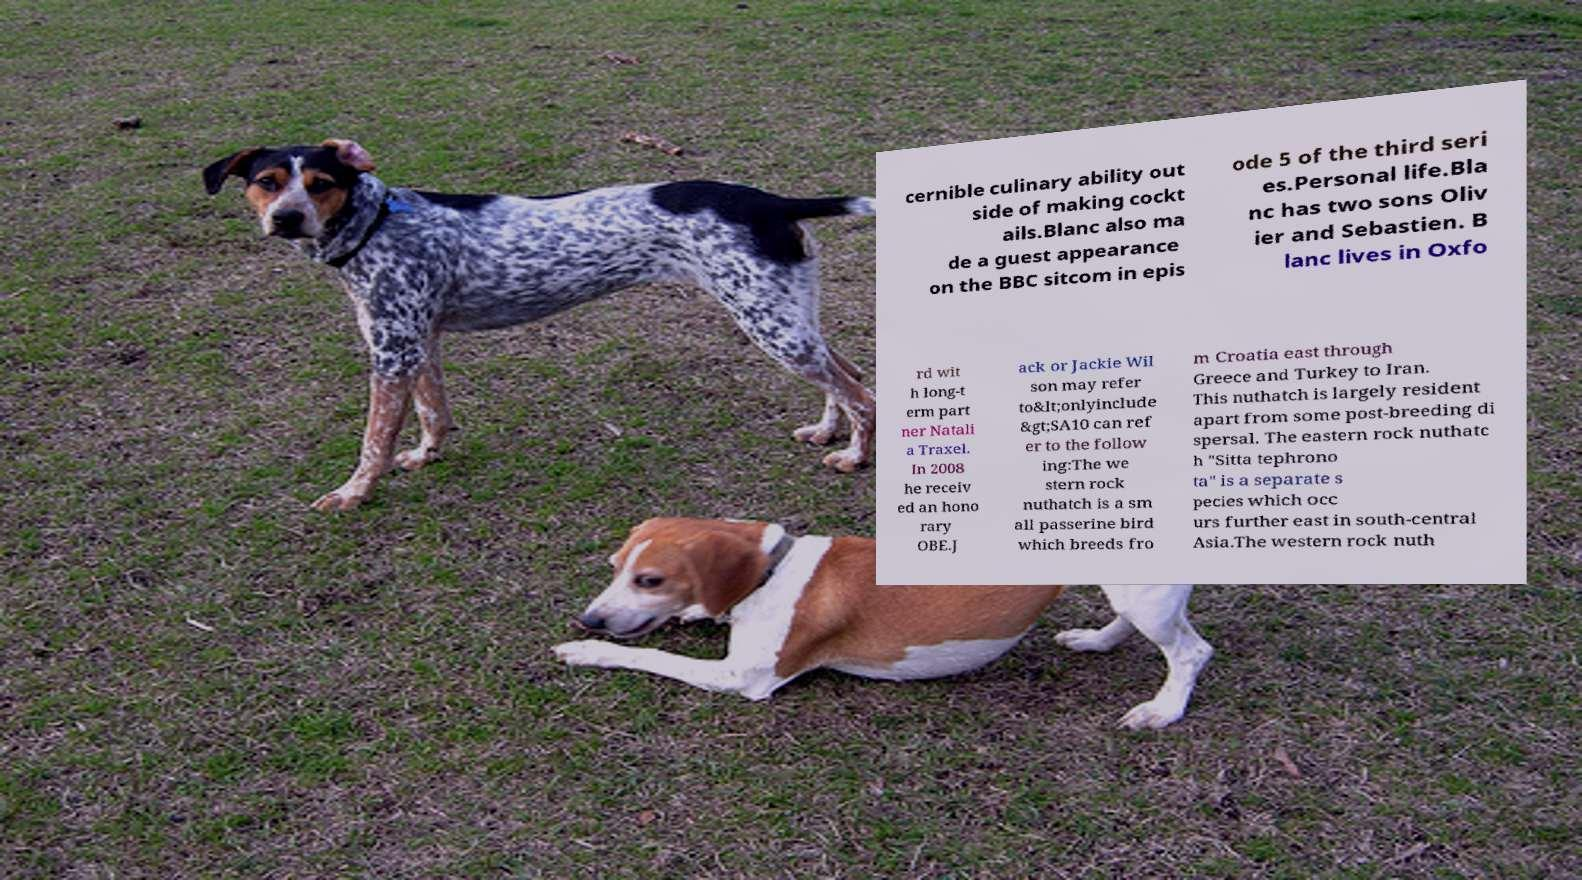Please read and relay the text visible in this image. What does it say? cernible culinary ability out side of making cockt ails.Blanc also ma de a guest appearance on the BBC sitcom in epis ode 5 of the third seri es.Personal life.Bla nc has two sons Oliv ier and Sebastien. B lanc lives in Oxfo rd wit h long-t erm part ner Natali a Traxel. In 2008 he receiv ed an hono rary OBE.J ack or Jackie Wil son may refer to&lt;onlyinclude &gt;SA10 can ref er to the follow ing:The we stern rock nuthatch is a sm all passerine bird which breeds fro m Croatia east through Greece and Turkey to Iran. This nuthatch is largely resident apart from some post-breeding di spersal. The eastern rock nuthatc h "Sitta tephrono ta" is a separate s pecies which occ urs further east in south-central Asia.The western rock nuth 